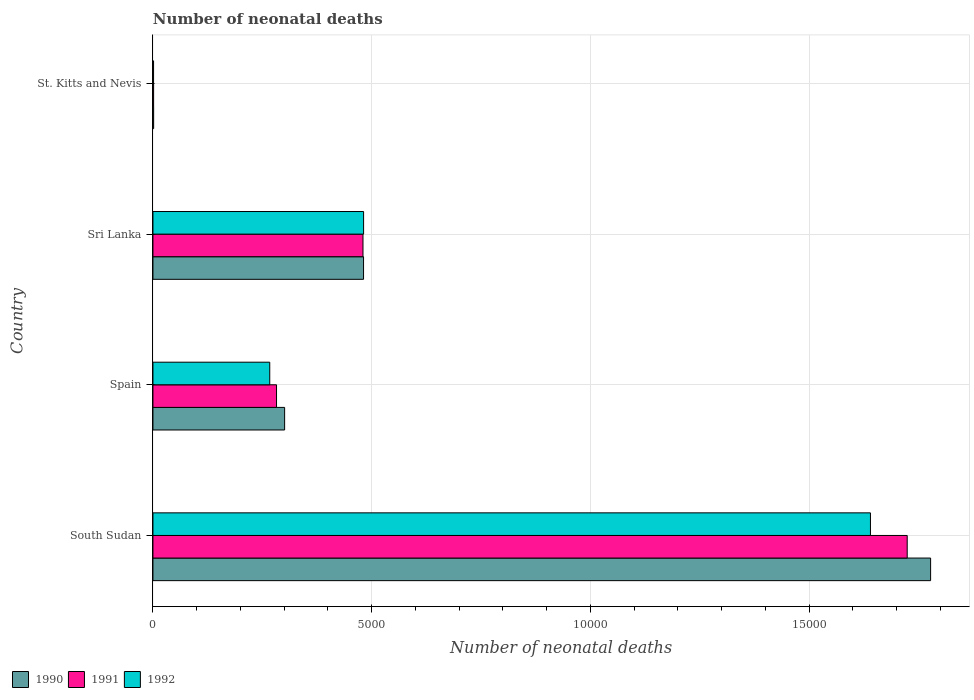Are the number of bars per tick equal to the number of legend labels?
Your response must be concise. Yes. Are the number of bars on each tick of the Y-axis equal?
Give a very brief answer. Yes. What is the label of the 3rd group of bars from the top?
Offer a terse response. Spain. In how many cases, is the number of bars for a given country not equal to the number of legend labels?
Your answer should be compact. 0. What is the number of neonatal deaths in in 1991 in Sri Lanka?
Your response must be concise. 4801. Across all countries, what is the maximum number of neonatal deaths in in 1992?
Ensure brevity in your answer.  1.64e+04. Across all countries, what is the minimum number of neonatal deaths in in 1992?
Provide a short and direct response. 14. In which country was the number of neonatal deaths in in 1991 maximum?
Give a very brief answer. South Sudan. In which country was the number of neonatal deaths in in 1990 minimum?
Offer a very short reply. St. Kitts and Nevis. What is the total number of neonatal deaths in in 1990 in the graph?
Give a very brief answer. 2.56e+04. What is the difference between the number of neonatal deaths in in 1991 in South Sudan and that in Spain?
Your answer should be compact. 1.44e+04. What is the difference between the number of neonatal deaths in in 1991 in Sri Lanka and the number of neonatal deaths in in 1992 in Spain?
Provide a short and direct response. 2131. What is the average number of neonatal deaths in in 1992 per country?
Give a very brief answer. 5975. What is the difference between the number of neonatal deaths in in 1992 and number of neonatal deaths in in 1990 in St. Kitts and Nevis?
Make the answer very short. -2. What is the ratio of the number of neonatal deaths in in 1991 in Spain to that in St. Kitts and Nevis?
Ensure brevity in your answer.  188.33. Is the number of neonatal deaths in in 1992 in South Sudan less than that in St. Kitts and Nevis?
Provide a succinct answer. No. What is the difference between the highest and the second highest number of neonatal deaths in in 1992?
Give a very brief answer. 1.16e+04. What is the difference between the highest and the lowest number of neonatal deaths in in 1992?
Offer a very short reply. 1.64e+04. In how many countries, is the number of neonatal deaths in in 1991 greater than the average number of neonatal deaths in in 1991 taken over all countries?
Offer a terse response. 1. Is the sum of the number of neonatal deaths in in 1991 in South Sudan and Sri Lanka greater than the maximum number of neonatal deaths in in 1990 across all countries?
Provide a short and direct response. Yes. What does the 3rd bar from the top in South Sudan represents?
Offer a terse response. 1990. Is it the case that in every country, the sum of the number of neonatal deaths in in 1992 and number of neonatal deaths in in 1991 is greater than the number of neonatal deaths in in 1990?
Your answer should be compact. Yes. Where does the legend appear in the graph?
Provide a short and direct response. Bottom left. How are the legend labels stacked?
Your answer should be very brief. Horizontal. What is the title of the graph?
Provide a succinct answer. Number of neonatal deaths. Does "1984" appear as one of the legend labels in the graph?
Keep it short and to the point. No. What is the label or title of the X-axis?
Your answer should be compact. Number of neonatal deaths. What is the label or title of the Y-axis?
Make the answer very short. Country. What is the Number of neonatal deaths of 1990 in South Sudan?
Your answer should be compact. 1.78e+04. What is the Number of neonatal deaths in 1991 in South Sudan?
Provide a short and direct response. 1.72e+04. What is the Number of neonatal deaths in 1992 in South Sudan?
Provide a succinct answer. 1.64e+04. What is the Number of neonatal deaths in 1990 in Spain?
Provide a short and direct response. 3010. What is the Number of neonatal deaths in 1991 in Spain?
Your answer should be compact. 2825. What is the Number of neonatal deaths of 1992 in Spain?
Your response must be concise. 2670. What is the Number of neonatal deaths in 1990 in Sri Lanka?
Keep it short and to the point. 4814. What is the Number of neonatal deaths of 1991 in Sri Lanka?
Keep it short and to the point. 4801. What is the Number of neonatal deaths in 1992 in Sri Lanka?
Provide a short and direct response. 4815. What is the Number of neonatal deaths of 1990 in St. Kitts and Nevis?
Keep it short and to the point. 16. Across all countries, what is the maximum Number of neonatal deaths of 1990?
Offer a terse response. 1.78e+04. Across all countries, what is the maximum Number of neonatal deaths in 1991?
Your response must be concise. 1.72e+04. Across all countries, what is the maximum Number of neonatal deaths of 1992?
Ensure brevity in your answer.  1.64e+04. Across all countries, what is the minimum Number of neonatal deaths in 1990?
Ensure brevity in your answer.  16. Across all countries, what is the minimum Number of neonatal deaths in 1992?
Offer a very short reply. 14. What is the total Number of neonatal deaths of 1990 in the graph?
Provide a succinct answer. 2.56e+04. What is the total Number of neonatal deaths in 1991 in the graph?
Provide a short and direct response. 2.49e+04. What is the total Number of neonatal deaths of 1992 in the graph?
Your answer should be compact. 2.39e+04. What is the difference between the Number of neonatal deaths of 1990 in South Sudan and that in Spain?
Provide a short and direct response. 1.48e+04. What is the difference between the Number of neonatal deaths in 1991 in South Sudan and that in Spain?
Your response must be concise. 1.44e+04. What is the difference between the Number of neonatal deaths in 1992 in South Sudan and that in Spain?
Keep it short and to the point. 1.37e+04. What is the difference between the Number of neonatal deaths in 1990 in South Sudan and that in Sri Lanka?
Offer a very short reply. 1.30e+04. What is the difference between the Number of neonatal deaths of 1991 in South Sudan and that in Sri Lanka?
Keep it short and to the point. 1.24e+04. What is the difference between the Number of neonatal deaths in 1992 in South Sudan and that in Sri Lanka?
Give a very brief answer. 1.16e+04. What is the difference between the Number of neonatal deaths of 1990 in South Sudan and that in St. Kitts and Nevis?
Offer a terse response. 1.78e+04. What is the difference between the Number of neonatal deaths of 1991 in South Sudan and that in St. Kitts and Nevis?
Offer a very short reply. 1.72e+04. What is the difference between the Number of neonatal deaths in 1992 in South Sudan and that in St. Kitts and Nevis?
Give a very brief answer. 1.64e+04. What is the difference between the Number of neonatal deaths of 1990 in Spain and that in Sri Lanka?
Keep it short and to the point. -1804. What is the difference between the Number of neonatal deaths of 1991 in Spain and that in Sri Lanka?
Keep it short and to the point. -1976. What is the difference between the Number of neonatal deaths in 1992 in Spain and that in Sri Lanka?
Make the answer very short. -2145. What is the difference between the Number of neonatal deaths of 1990 in Spain and that in St. Kitts and Nevis?
Your response must be concise. 2994. What is the difference between the Number of neonatal deaths in 1991 in Spain and that in St. Kitts and Nevis?
Provide a short and direct response. 2810. What is the difference between the Number of neonatal deaths of 1992 in Spain and that in St. Kitts and Nevis?
Ensure brevity in your answer.  2656. What is the difference between the Number of neonatal deaths of 1990 in Sri Lanka and that in St. Kitts and Nevis?
Give a very brief answer. 4798. What is the difference between the Number of neonatal deaths of 1991 in Sri Lanka and that in St. Kitts and Nevis?
Give a very brief answer. 4786. What is the difference between the Number of neonatal deaths in 1992 in Sri Lanka and that in St. Kitts and Nevis?
Your answer should be very brief. 4801. What is the difference between the Number of neonatal deaths of 1990 in South Sudan and the Number of neonatal deaths of 1991 in Spain?
Provide a succinct answer. 1.50e+04. What is the difference between the Number of neonatal deaths in 1990 in South Sudan and the Number of neonatal deaths in 1992 in Spain?
Your answer should be compact. 1.51e+04. What is the difference between the Number of neonatal deaths of 1991 in South Sudan and the Number of neonatal deaths of 1992 in Spain?
Provide a short and direct response. 1.46e+04. What is the difference between the Number of neonatal deaths in 1990 in South Sudan and the Number of neonatal deaths in 1991 in Sri Lanka?
Give a very brief answer. 1.30e+04. What is the difference between the Number of neonatal deaths in 1990 in South Sudan and the Number of neonatal deaths in 1992 in Sri Lanka?
Give a very brief answer. 1.30e+04. What is the difference between the Number of neonatal deaths in 1991 in South Sudan and the Number of neonatal deaths in 1992 in Sri Lanka?
Make the answer very short. 1.24e+04. What is the difference between the Number of neonatal deaths in 1990 in South Sudan and the Number of neonatal deaths in 1991 in St. Kitts and Nevis?
Your response must be concise. 1.78e+04. What is the difference between the Number of neonatal deaths of 1990 in South Sudan and the Number of neonatal deaths of 1992 in St. Kitts and Nevis?
Provide a succinct answer. 1.78e+04. What is the difference between the Number of neonatal deaths of 1991 in South Sudan and the Number of neonatal deaths of 1992 in St. Kitts and Nevis?
Your response must be concise. 1.72e+04. What is the difference between the Number of neonatal deaths of 1990 in Spain and the Number of neonatal deaths of 1991 in Sri Lanka?
Your response must be concise. -1791. What is the difference between the Number of neonatal deaths of 1990 in Spain and the Number of neonatal deaths of 1992 in Sri Lanka?
Make the answer very short. -1805. What is the difference between the Number of neonatal deaths of 1991 in Spain and the Number of neonatal deaths of 1992 in Sri Lanka?
Keep it short and to the point. -1990. What is the difference between the Number of neonatal deaths in 1990 in Spain and the Number of neonatal deaths in 1991 in St. Kitts and Nevis?
Provide a succinct answer. 2995. What is the difference between the Number of neonatal deaths of 1990 in Spain and the Number of neonatal deaths of 1992 in St. Kitts and Nevis?
Offer a terse response. 2996. What is the difference between the Number of neonatal deaths of 1991 in Spain and the Number of neonatal deaths of 1992 in St. Kitts and Nevis?
Your response must be concise. 2811. What is the difference between the Number of neonatal deaths of 1990 in Sri Lanka and the Number of neonatal deaths of 1991 in St. Kitts and Nevis?
Make the answer very short. 4799. What is the difference between the Number of neonatal deaths of 1990 in Sri Lanka and the Number of neonatal deaths of 1992 in St. Kitts and Nevis?
Ensure brevity in your answer.  4800. What is the difference between the Number of neonatal deaths of 1991 in Sri Lanka and the Number of neonatal deaths of 1992 in St. Kitts and Nevis?
Give a very brief answer. 4787. What is the average Number of neonatal deaths in 1990 per country?
Keep it short and to the point. 6404. What is the average Number of neonatal deaths in 1991 per country?
Your answer should be very brief. 6220.5. What is the average Number of neonatal deaths of 1992 per country?
Your response must be concise. 5975. What is the difference between the Number of neonatal deaths of 1990 and Number of neonatal deaths of 1991 in South Sudan?
Your answer should be compact. 535. What is the difference between the Number of neonatal deaths in 1990 and Number of neonatal deaths in 1992 in South Sudan?
Offer a very short reply. 1375. What is the difference between the Number of neonatal deaths in 1991 and Number of neonatal deaths in 1992 in South Sudan?
Ensure brevity in your answer.  840. What is the difference between the Number of neonatal deaths in 1990 and Number of neonatal deaths in 1991 in Spain?
Keep it short and to the point. 185. What is the difference between the Number of neonatal deaths of 1990 and Number of neonatal deaths of 1992 in Spain?
Keep it short and to the point. 340. What is the difference between the Number of neonatal deaths in 1991 and Number of neonatal deaths in 1992 in Spain?
Your response must be concise. 155. What is the difference between the Number of neonatal deaths of 1990 and Number of neonatal deaths of 1991 in Sri Lanka?
Keep it short and to the point. 13. What is the difference between the Number of neonatal deaths of 1990 and Number of neonatal deaths of 1992 in Sri Lanka?
Offer a very short reply. -1. What is the difference between the Number of neonatal deaths of 1991 and Number of neonatal deaths of 1992 in Sri Lanka?
Ensure brevity in your answer.  -14. What is the difference between the Number of neonatal deaths of 1991 and Number of neonatal deaths of 1992 in St. Kitts and Nevis?
Provide a short and direct response. 1. What is the ratio of the Number of neonatal deaths of 1990 in South Sudan to that in Spain?
Provide a short and direct response. 5.91. What is the ratio of the Number of neonatal deaths of 1991 in South Sudan to that in Spain?
Offer a very short reply. 6.1. What is the ratio of the Number of neonatal deaths in 1992 in South Sudan to that in Spain?
Make the answer very short. 6.14. What is the ratio of the Number of neonatal deaths of 1990 in South Sudan to that in Sri Lanka?
Give a very brief answer. 3.69. What is the ratio of the Number of neonatal deaths of 1991 in South Sudan to that in Sri Lanka?
Keep it short and to the point. 3.59. What is the ratio of the Number of neonatal deaths of 1992 in South Sudan to that in Sri Lanka?
Keep it short and to the point. 3.41. What is the ratio of the Number of neonatal deaths in 1990 in South Sudan to that in St. Kitts and Nevis?
Ensure brevity in your answer.  1111. What is the ratio of the Number of neonatal deaths of 1991 in South Sudan to that in St. Kitts and Nevis?
Make the answer very short. 1149.4. What is the ratio of the Number of neonatal deaths of 1992 in South Sudan to that in St. Kitts and Nevis?
Your answer should be compact. 1171.5. What is the ratio of the Number of neonatal deaths in 1990 in Spain to that in Sri Lanka?
Ensure brevity in your answer.  0.63. What is the ratio of the Number of neonatal deaths in 1991 in Spain to that in Sri Lanka?
Ensure brevity in your answer.  0.59. What is the ratio of the Number of neonatal deaths in 1992 in Spain to that in Sri Lanka?
Your answer should be very brief. 0.55. What is the ratio of the Number of neonatal deaths in 1990 in Spain to that in St. Kitts and Nevis?
Offer a terse response. 188.12. What is the ratio of the Number of neonatal deaths in 1991 in Spain to that in St. Kitts and Nevis?
Offer a very short reply. 188.33. What is the ratio of the Number of neonatal deaths of 1992 in Spain to that in St. Kitts and Nevis?
Make the answer very short. 190.71. What is the ratio of the Number of neonatal deaths in 1990 in Sri Lanka to that in St. Kitts and Nevis?
Make the answer very short. 300.88. What is the ratio of the Number of neonatal deaths of 1991 in Sri Lanka to that in St. Kitts and Nevis?
Keep it short and to the point. 320.07. What is the ratio of the Number of neonatal deaths of 1992 in Sri Lanka to that in St. Kitts and Nevis?
Your answer should be very brief. 343.93. What is the difference between the highest and the second highest Number of neonatal deaths of 1990?
Provide a short and direct response. 1.30e+04. What is the difference between the highest and the second highest Number of neonatal deaths of 1991?
Offer a very short reply. 1.24e+04. What is the difference between the highest and the second highest Number of neonatal deaths of 1992?
Offer a terse response. 1.16e+04. What is the difference between the highest and the lowest Number of neonatal deaths in 1990?
Offer a very short reply. 1.78e+04. What is the difference between the highest and the lowest Number of neonatal deaths in 1991?
Offer a terse response. 1.72e+04. What is the difference between the highest and the lowest Number of neonatal deaths in 1992?
Your answer should be very brief. 1.64e+04. 